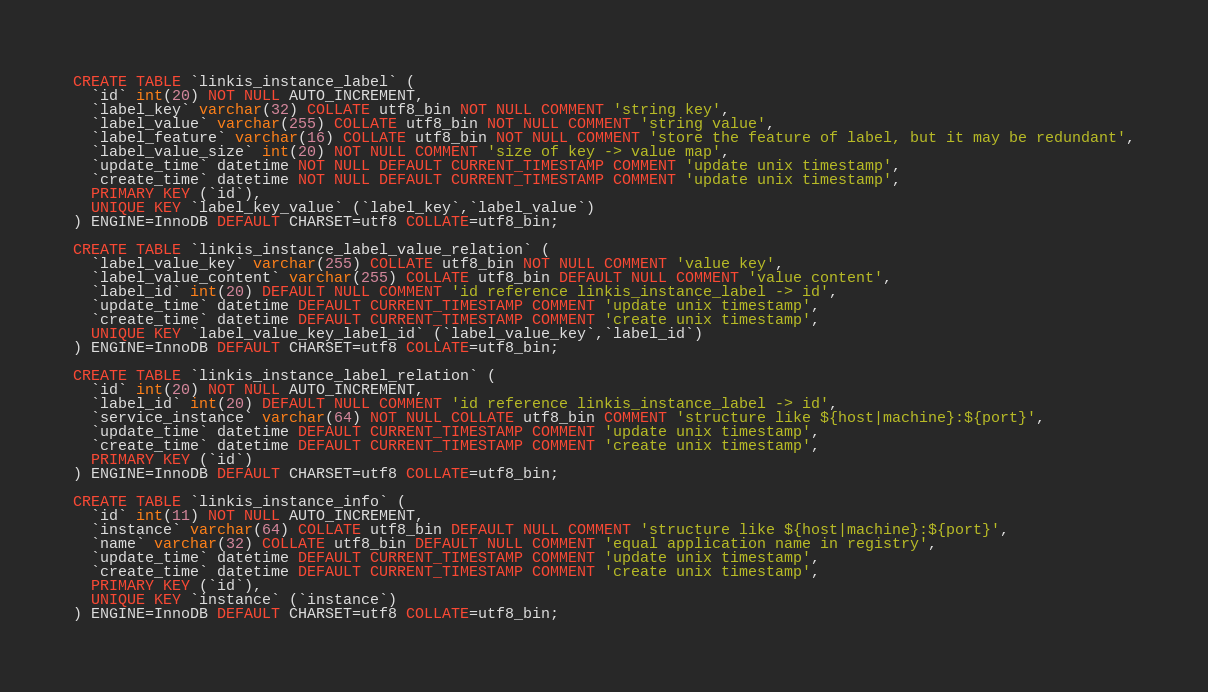Convert code to text. <code><loc_0><loc_0><loc_500><loc_500><_SQL_>CREATE TABLE `linkis_instance_label` (
  `id` int(20) NOT NULL AUTO_INCREMENT,
  `label_key` varchar(32) COLLATE utf8_bin NOT NULL COMMENT 'string key',
  `label_value` varchar(255) COLLATE utf8_bin NOT NULL COMMENT 'string value',
  `label_feature` varchar(16) COLLATE utf8_bin NOT NULL COMMENT 'store the feature of label, but it may be redundant',
  `label_value_size` int(20) NOT NULL COMMENT 'size of key -> value map',
  `update_time` datetime NOT NULL DEFAULT CURRENT_TIMESTAMP COMMENT 'update unix timestamp',
  `create_time` datetime NOT NULL DEFAULT CURRENT_TIMESTAMP COMMENT 'update unix timestamp',
  PRIMARY KEY (`id`),
  UNIQUE KEY `label_key_value` (`label_key`,`label_value`)
) ENGINE=InnoDB DEFAULT CHARSET=utf8 COLLATE=utf8_bin;

CREATE TABLE `linkis_instance_label_value_relation` (
  `label_value_key` varchar(255) COLLATE utf8_bin NOT NULL COMMENT 'value key',
  `label_value_content` varchar(255) COLLATE utf8_bin DEFAULT NULL COMMENT 'value content',
  `label_id` int(20) DEFAULT NULL COMMENT 'id reference linkis_instance_label -> id',
  `update_time` datetime DEFAULT CURRENT_TIMESTAMP COMMENT 'update unix timestamp',
  `create_time` datetime DEFAULT CURRENT_TIMESTAMP COMMENT 'create unix timestamp',
  UNIQUE KEY `label_value_key_label_id` (`label_value_key`,`label_id`)
) ENGINE=InnoDB DEFAULT CHARSET=utf8 COLLATE=utf8_bin;

CREATE TABLE `linkis_instance_label_relation` (
  `id` int(20) NOT NULL AUTO_INCREMENT,
  `label_id` int(20) DEFAULT NULL COMMENT 'id reference linkis_instance_label -> id',
  `service_instance` varchar(64) NOT NULL COLLATE utf8_bin COMMENT 'structure like ${host|machine}:${port}',
  `update_time` datetime DEFAULT CURRENT_TIMESTAMP COMMENT 'update unix timestamp',
  `create_time` datetime DEFAULT CURRENT_TIMESTAMP COMMENT 'create unix timestamp',
  PRIMARY KEY (`id`)
) ENGINE=InnoDB DEFAULT CHARSET=utf8 COLLATE=utf8_bin;

CREATE TABLE `linkis_instance_info` (
  `id` int(11) NOT NULL AUTO_INCREMENT,
  `instance` varchar(64) COLLATE utf8_bin DEFAULT NULL COMMENT 'structure like ${host|machine}:${port}',
  `name` varchar(32) COLLATE utf8_bin DEFAULT NULL COMMENT 'equal application name in registry',
  `update_time` datetime DEFAULT CURRENT_TIMESTAMP COMMENT 'update unix timestamp',
  `create_time` datetime DEFAULT CURRENT_TIMESTAMP COMMENT 'create unix timestamp',
  PRIMARY KEY (`id`),
  UNIQUE KEY `instance` (`instance`)
) ENGINE=InnoDB DEFAULT CHARSET=utf8 COLLATE=utf8_bin;



</code> 